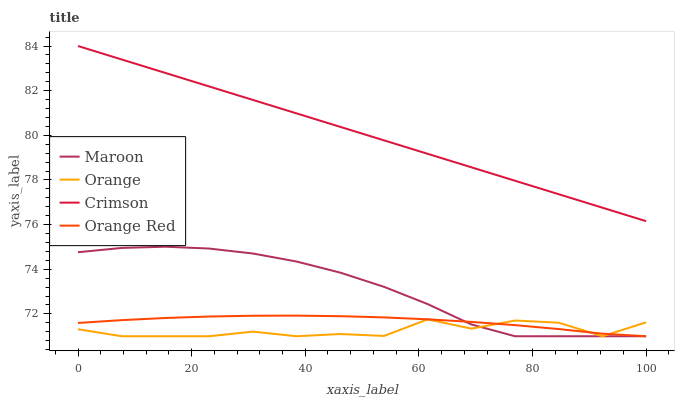Does Orange Red have the minimum area under the curve?
Answer yes or no. No. Does Orange Red have the maximum area under the curve?
Answer yes or no. No. Is Orange Red the smoothest?
Answer yes or no. No. Is Orange Red the roughest?
Answer yes or no. No. Does Crimson have the lowest value?
Answer yes or no. No. Does Orange Red have the highest value?
Answer yes or no. No. Is Orange less than Crimson?
Answer yes or no. Yes. Is Crimson greater than Orange?
Answer yes or no. Yes. Does Orange intersect Crimson?
Answer yes or no. No. 